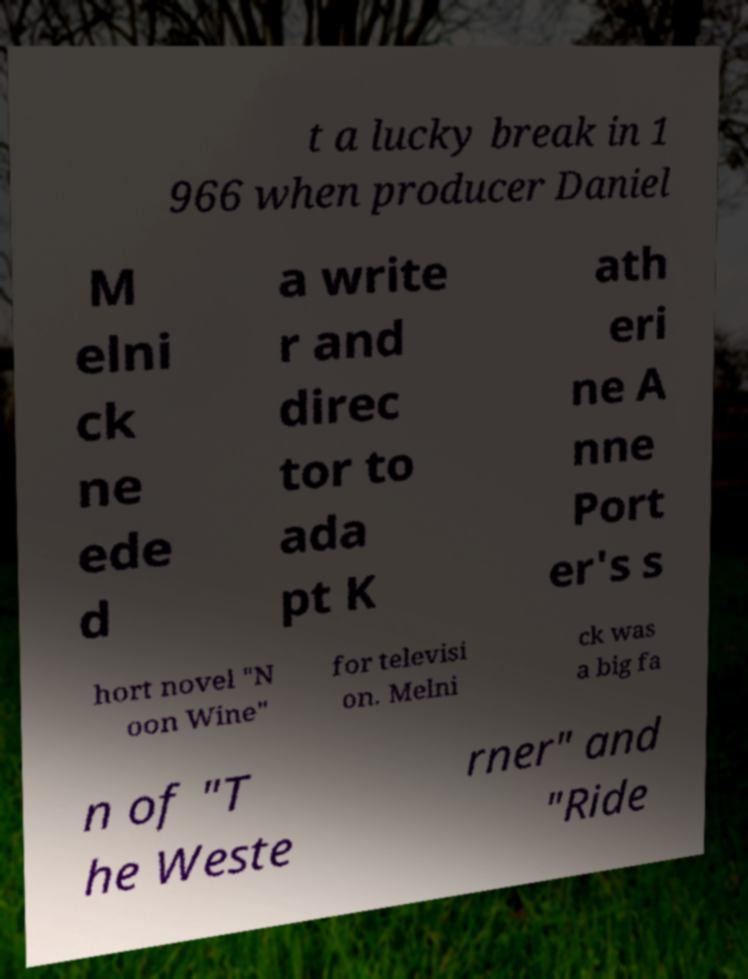Please read and relay the text visible in this image. What does it say? t a lucky break in 1 966 when producer Daniel M elni ck ne ede d a write r and direc tor to ada pt K ath eri ne A nne Port er's s hort novel "N oon Wine" for televisi on. Melni ck was a big fa n of "T he Weste rner" and "Ride 